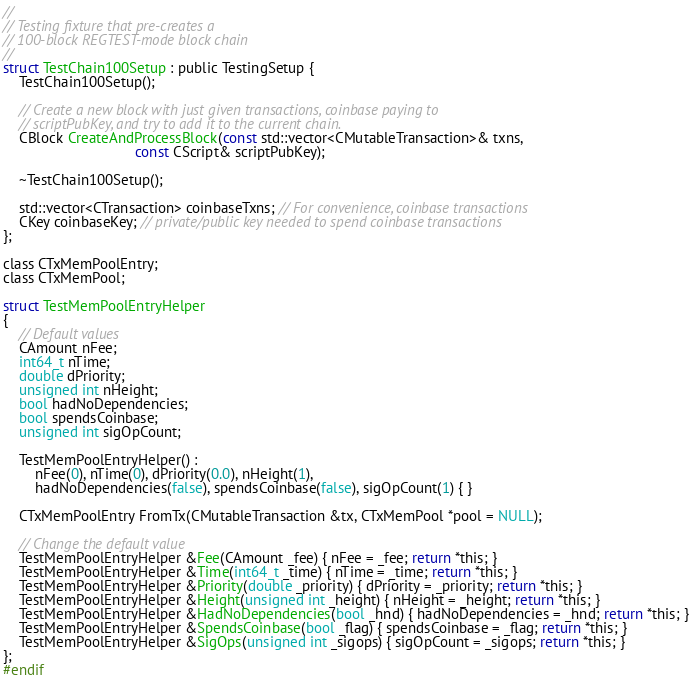<code> <loc_0><loc_0><loc_500><loc_500><_C_>//
// Testing fixture that pre-creates a
// 100-block REGTEST-mode block chain
//
struct TestChain100Setup : public TestingSetup {
    TestChain100Setup();

    // Create a new block with just given transactions, coinbase paying to
    // scriptPubKey, and try to add it to the current chain.
    CBlock CreateAndProcessBlock(const std::vector<CMutableTransaction>& txns,
                                 const CScript& scriptPubKey);

    ~TestChain100Setup();

    std::vector<CTransaction> coinbaseTxns; // For convenience, coinbase transactions
    CKey coinbaseKey; // private/public key needed to spend coinbase transactions
};

class CTxMemPoolEntry;
class CTxMemPool;

struct TestMemPoolEntryHelper
{
    // Default values
    CAmount nFee;
    int64_t nTime;
    double dPriority;
    unsigned int nHeight;
    bool hadNoDependencies;
    bool spendsCoinbase;
    unsigned int sigOpCount;
    
    TestMemPoolEntryHelper() :
        nFee(0), nTime(0), dPriority(0.0), nHeight(1),
        hadNoDependencies(false), spendsCoinbase(false), sigOpCount(1) { }
    
    CTxMemPoolEntry FromTx(CMutableTransaction &tx, CTxMemPool *pool = NULL);

    // Change the default value
    TestMemPoolEntryHelper &Fee(CAmount _fee) { nFee = _fee; return *this; }
    TestMemPoolEntryHelper &Time(int64_t _time) { nTime = _time; return *this; }
    TestMemPoolEntryHelper &Priority(double _priority) { dPriority = _priority; return *this; }
    TestMemPoolEntryHelper &Height(unsigned int _height) { nHeight = _height; return *this; }
    TestMemPoolEntryHelper &HadNoDependencies(bool _hnd) { hadNoDependencies = _hnd; return *this; }
    TestMemPoolEntryHelper &SpendsCoinbase(bool _flag) { spendsCoinbase = _flag; return *this; }
    TestMemPoolEntryHelper &SigOps(unsigned int _sigops) { sigOpCount = _sigops; return *this; }
};
#endif
</code> 